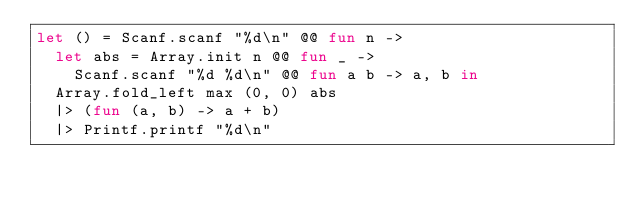<code> <loc_0><loc_0><loc_500><loc_500><_OCaml_>let () = Scanf.scanf "%d\n" @@ fun n ->
  let abs = Array.init n @@ fun _ ->
    Scanf.scanf "%d %d\n" @@ fun a b -> a, b in
  Array.fold_left max (0, 0) abs
  |> (fun (a, b) -> a + b)
  |> Printf.printf "%d\n"
</code> 